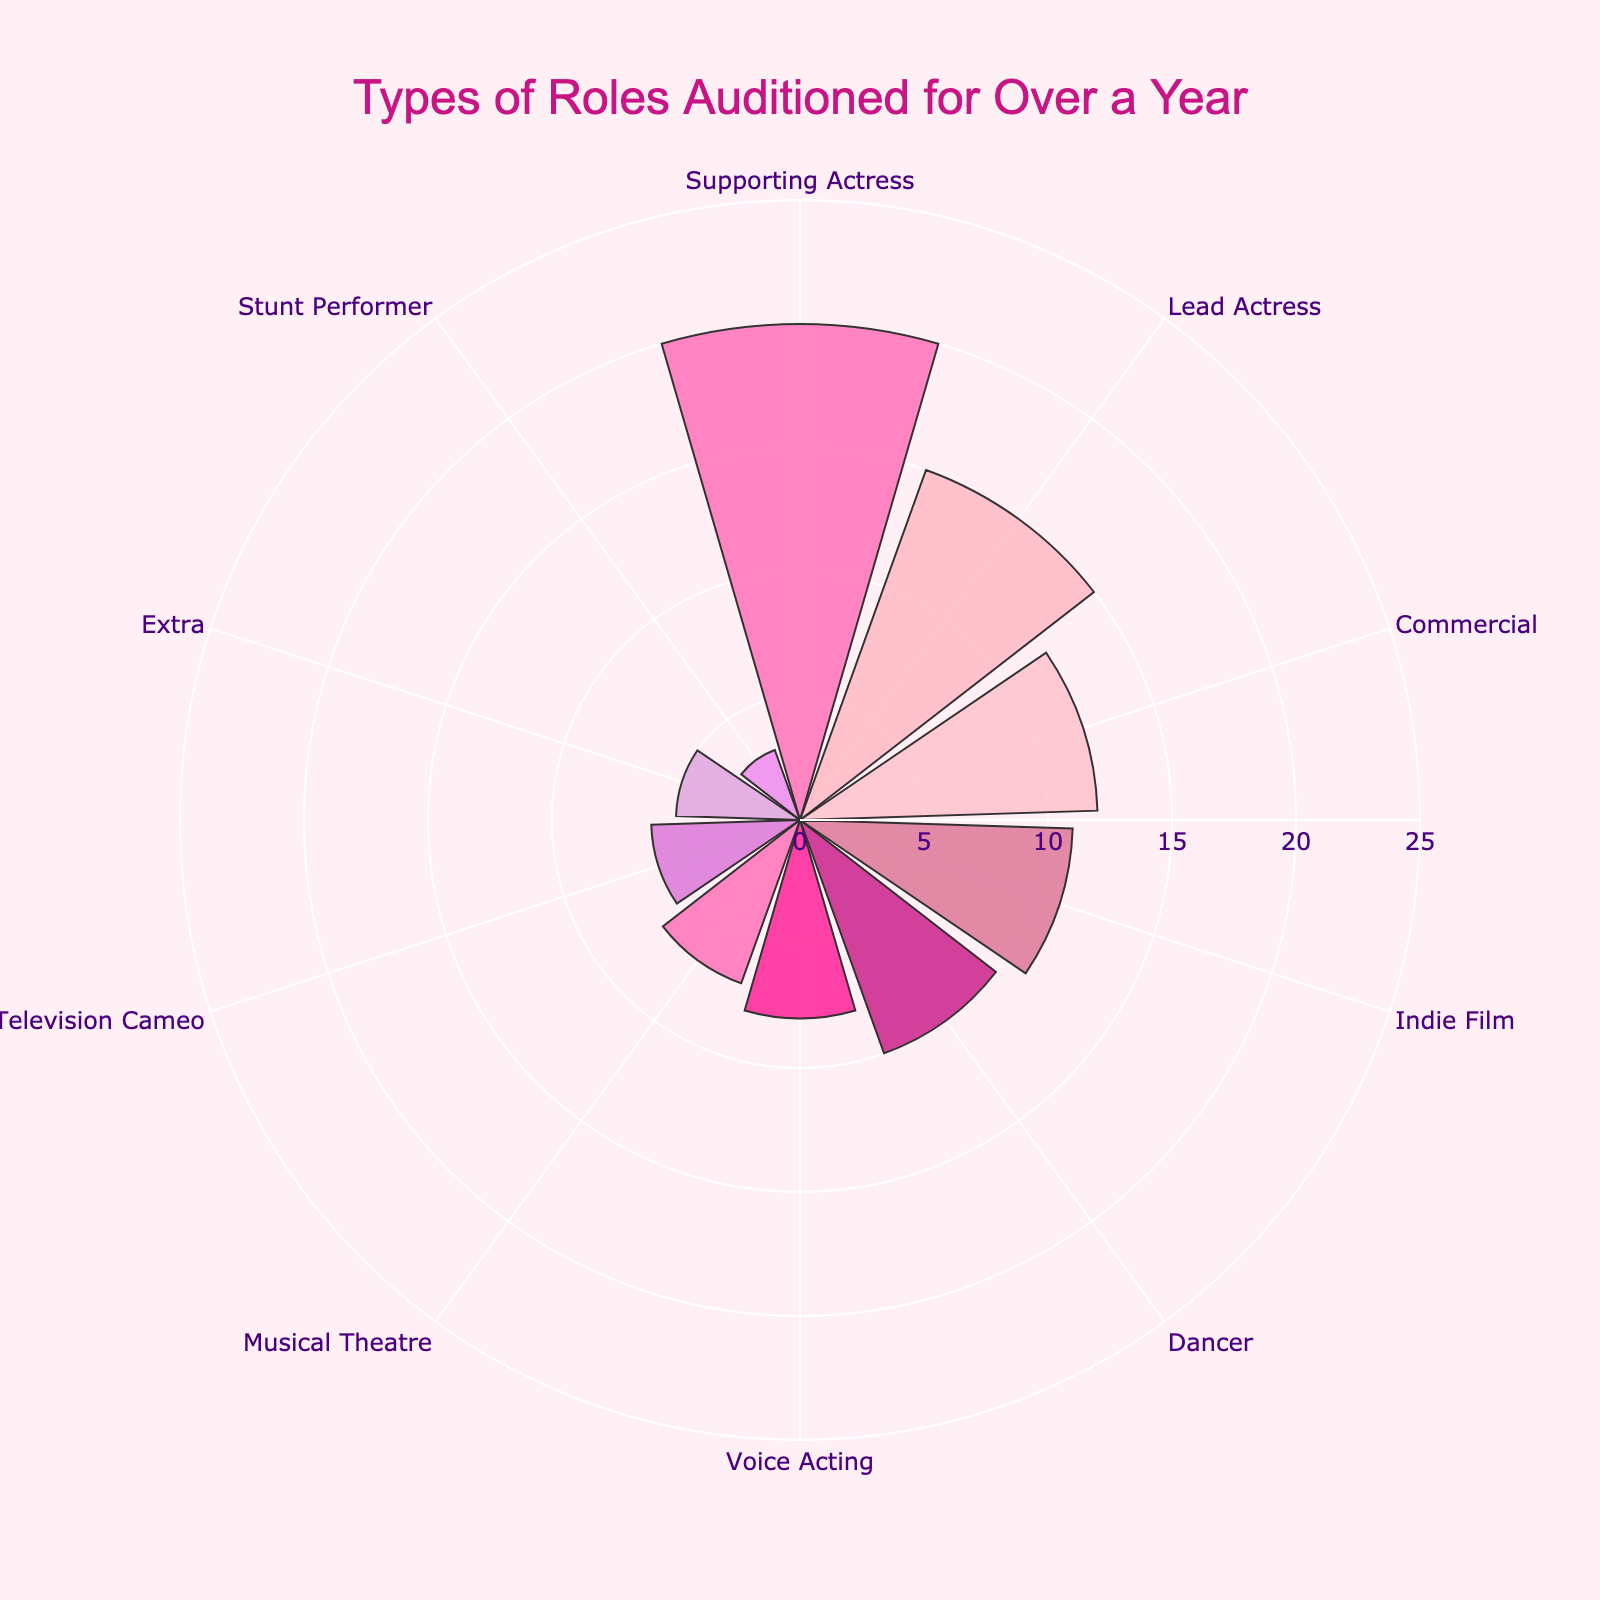What is the title of the chart? The title of the chart is located at the top center and is written in a noticeable font size and color.
Answer: Types of Roles Auditioned for Over a Year What is the role with the highest number of auditions? By comparing the length of the bars, you can see which one extends the furthest from the center, indicating the highest number of auditions.
Answer: Supporting Actress How many roles have counts greater than 10? Identify the bars that reach numbers greater than 10 by referring to the radial axis. Count how many such bars there are.
Answer: 4 How many more auditions were there for Lead Actress compared to Dancer? Look at the counts for Lead Actress and Dancer, then subtract the count for Dancer from the count for Lead Actress. Lead Actress has 15 auditions, and Dancer has 10. So, 15 - 10.
Answer: 5 Which role has the fewest number of auditions? Determine the role with the bar that extends the least from the center, indicating the smallest count.
Answer: Stunt Performer What is the total number of auditions across all roles? Add up the counts for each role. 15+20+8+12+5+10+3+7+6+11.
Answer: 97 On average, how many auditions were there per role? Divide the total number of auditions by the number of roles. 97 (total) / 10 (roles)
Answer: 9.7 Which role categories have counts that fall below the average number of auditions per role? First, calculate the average number of auditions per role (which is 9.7). Then, evaluate which roles have counts less than this average. Roles with fewer than 9.7 auditions: Voice Acting, Extra, Stunt Performer, Musical Theatre, Television Cameo.
Answer: Voice Acting, Extra, Stunt Performer, Musical Theatre, Television Cameo What is the combined count for Musical Theatre and Indie Film? Add the counts for Musical Theatre and Indie Film. 7 (Musical Theatre) + 11 (Indie Film)
Answer: 18 How does the audition count for Commercial roles compare to Voice Acting roles? Compare the counts for Commercial (12) and Voice Acting (8) roles. Since 12 is greater than 8, there are more auditions for Commercial roles than for Voice Acting roles.
Answer: More for Commercial roles than Voice Acting roles 